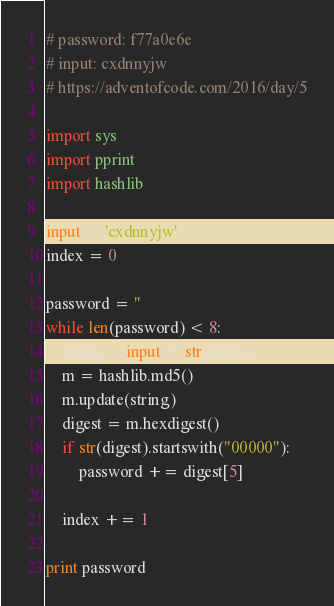<code> <loc_0><loc_0><loc_500><loc_500><_Python_># password: f77a0e6e
# input: cxdnnyjw
# https://adventofcode.com/2016/day/5

import sys
import pprint
import hashlib

input = 'cxdnnyjw'
index = 0

password = ''
while len(password) < 8:
    string = input + str(index)
    m = hashlib.md5()
    m.update(string)
    digest = m.hexdigest()
    if str(digest).startswith("00000"):
        password += digest[5]

    index += 1

print password</code> 